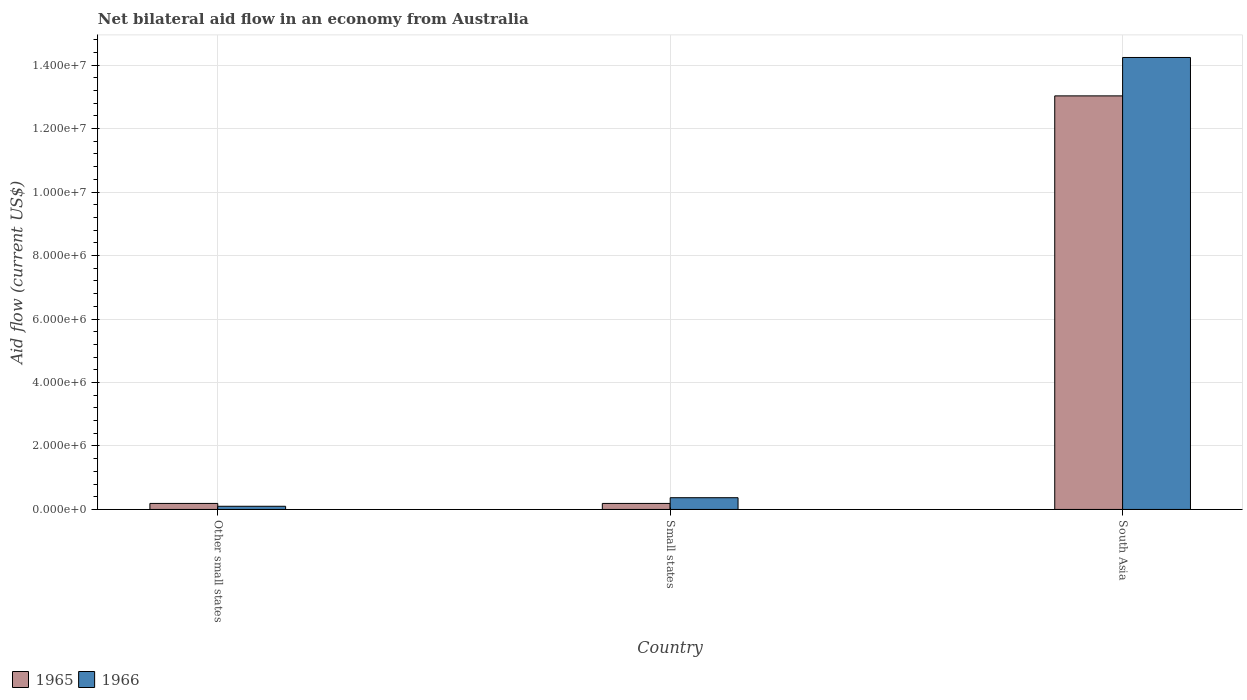How many different coloured bars are there?
Offer a terse response. 2. Are the number of bars per tick equal to the number of legend labels?
Keep it short and to the point. Yes. How many bars are there on the 2nd tick from the left?
Ensure brevity in your answer.  2. How many bars are there on the 1st tick from the right?
Keep it short and to the point. 2. What is the label of the 2nd group of bars from the left?
Your answer should be very brief. Small states. In how many cases, is the number of bars for a given country not equal to the number of legend labels?
Make the answer very short. 0. What is the net bilateral aid flow in 1965 in South Asia?
Keep it short and to the point. 1.30e+07. Across all countries, what is the maximum net bilateral aid flow in 1965?
Make the answer very short. 1.30e+07. In which country was the net bilateral aid flow in 1965 maximum?
Ensure brevity in your answer.  South Asia. In which country was the net bilateral aid flow in 1965 minimum?
Offer a terse response. Other small states. What is the total net bilateral aid flow in 1966 in the graph?
Provide a succinct answer. 1.47e+07. What is the difference between the net bilateral aid flow in 1966 in Other small states and that in South Asia?
Offer a terse response. -1.41e+07. What is the difference between the net bilateral aid flow in 1966 in Other small states and the net bilateral aid flow in 1965 in South Asia?
Ensure brevity in your answer.  -1.29e+07. What is the average net bilateral aid flow in 1966 per country?
Your answer should be compact. 4.90e+06. In how many countries, is the net bilateral aid flow in 1966 greater than 7600000 US$?
Your answer should be very brief. 1. What is the ratio of the net bilateral aid flow in 1965 in Small states to that in South Asia?
Offer a terse response. 0.01. What is the difference between the highest and the second highest net bilateral aid flow in 1966?
Give a very brief answer. 1.39e+07. What is the difference between the highest and the lowest net bilateral aid flow in 1965?
Your response must be concise. 1.28e+07. Is the sum of the net bilateral aid flow in 1966 in Other small states and South Asia greater than the maximum net bilateral aid flow in 1965 across all countries?
Give a very brief answer. Yes. What does the 2nd bar from the left in Small states represents?
Offer a very short reply. 1966. What does the 2nd bar from the right in Other small states represents?
Offer a very short reply. 1965. Are all the bars in the graph horizontal?
Your answer should be compact. No. Are the values on the major ticks of Y-axis written in scientific E-notation?
Your response must be concise. Yes. Does the graph contain any zero values?
Offer a terse response. No. Where does the legend appear in the graph?
Your answer should be compact. Bottom left. How are the legend labels stacked?
Keep it short and to the point. Horizontal. What is the title of the graph?
Keep it short and to the point. Net bilateral aid flow in an economy from Australia. What is the label or title of the X-axis?
Make the answer very short. Country. What is the label or title of the Y-axis?
Make the answer very short. Aid flow (current US$). What is the Aid flow (current US$) in 1965 in Other small states?
Ensure brevity in your answer.  1.90e+05. What is the Aid flow (current US$) in 1966 in Other small states?
Give a very brief answer. 1.00e+05. What is the Aid flow (current US$) in 1965 in Small states?
Your answer should be compact. 1.90e+05. What is the Aid flow (current US$) of 1965 in South Asia?
Your answer should be compact. 1.30e+07. What is the Aid flow (current US$) in 1966 in South Asia?
Offer a terse response. 1.42e+07. Across all countries, what is the maximum Aid flow (current US$) in 1965?
Provide a short and direct response. 1.30e+07. Across all countries, what is the maximum Aid flow (current US$) in 1966?
Your answer should be compact. 1.42e+07. What is the total Aid flow (current US$) in 1965 in the graph?
Provide a short and direct response. 1.34e+07. What is the total Aid flow (current US$) in 1966 in the graph?
Offer a terse response. 1.47e+07. What is the difference between the Aid flow (current US$) in 1965 in Other small states and that in Small states?
Offer a terse response. 0. What is the difference between the Aid flow (current US$) of 1965 in Other small states and that in South Asia?
Provide a short and direct response. -1.28e+07. What is the difference between the Aid flow (current US$) in 1966 in Other small states and that in South Asia?
Offer a terse response. -1.41e+07. What is the difference between the Aid flow (current US$) of 1965 in Small states and that in South Asia?
Provide a succinct answer. -1.28e+07. What is the difference between the Aid flow (current US$) of 1966 in Small states and that in South Asia?
Make the answer very short. -1.39e+07. What is the difference between the Aid flow (current US$) in 1965 in Other small states and the Aid flow (current US$) in 1966 in South Asia?
Offer a very short reply. -1.40e+07. What is the difference between the Aid flow (current US$) in 1965 in Small states and the Aid flow (current US$) in 1966 in South Asia?
Provide a succinct answer. -1.40e+07. What is the average Aid flow (current US$) in 1965 per country?
Offer a terse response. 4.47e+06. What is the average Aid flow (current US$) in 1966 per country?
Offer a very short reply. 4.90e+06. What is the difference between the Aid flow (current US$) in 1965 and Aid flow (current US$) in 1966 in Other small states?
Offer a very short reply. 9.00e+04. What is the difference between the Aid flow (current US$) in 1965 and Aid flow (current US$) in 1966 in Small states?
Offer a very short reply. -1.80e+05. What is the difference between the Aid flow (current US$) of 1965 and Aid flow (current US$) of 1966 in South Asia?
Make the answer very short. -1.21e+06. What is the ratio of the Aid flow (current US$) in 1966 in Other small states to that in Small states?
Your response must be concise. 0.27. What is the ratio of the Aid flow (current US$) in 1965 in Other small states to that in South Asia?
Ensure brevity in your answer.  0.01. What is the ratio of the Aid flow (current US$) in 1966 in Other small states to that in South Asia?
Keep it short and to the point. 0.01. What is the ratio of the Aid flow (current US$) in 1965 in Small states to that in South Asia?
Your answer should be compact. 0.01. What is the ratio of the Aid flow (current US$) in 1966 in Small states to that in South Asia?
Provide a short and direct response. 0.03. What is the difference between the highest and the second highest Aid flow (current US$) of 1965?
Give a very brief answer. 1.28e+07. What is the difference between the highest and the second highest Aid flow (current US$) in 1966?
Provide a short and direct response. 1.39e+07. What is the difference between the highest and the lowest Aid flow (current US$) of 1965?
Provide a short and direct response. 1.28e+07. What is the difference between the highest and the lowest Aid flow (current US$) in 1966?
Keep it short and to the point. 1.41e+07. 